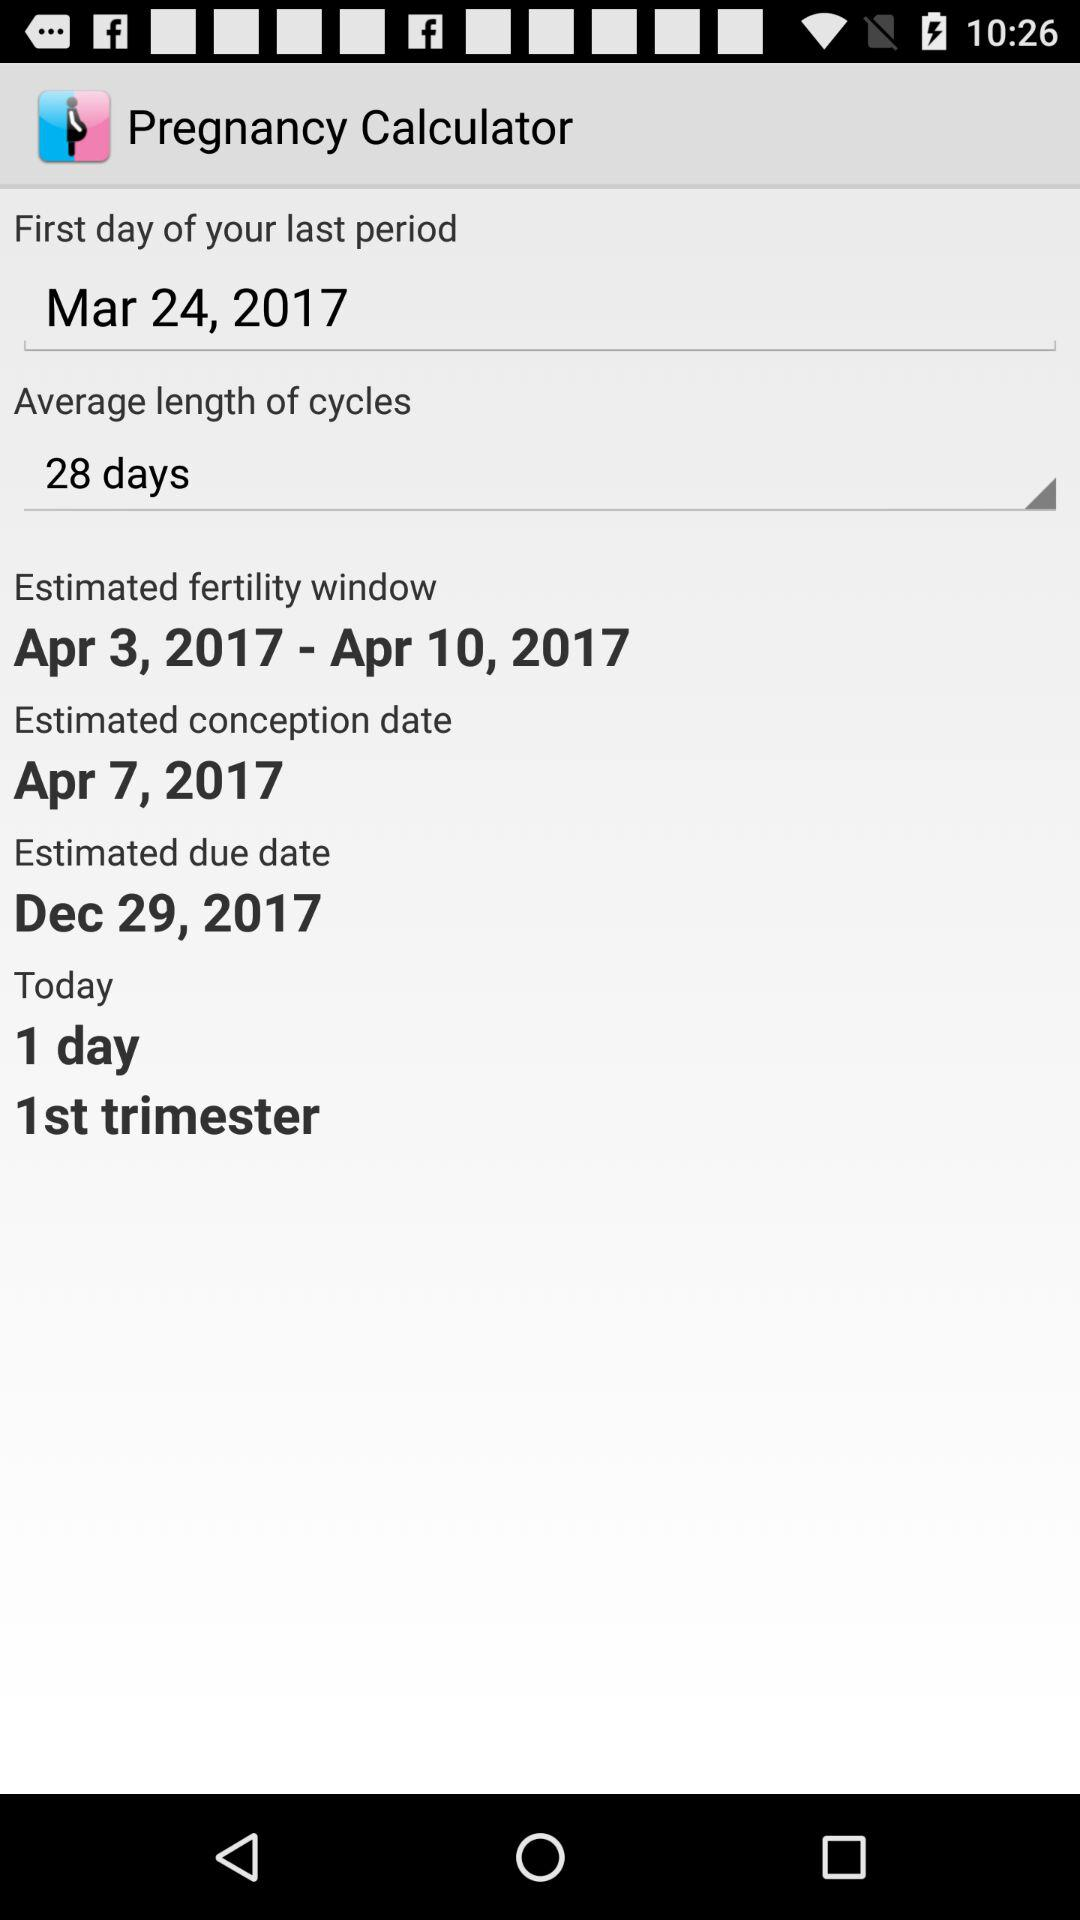What is the average length of a cycle? The average length of a cycle is 28 days. 